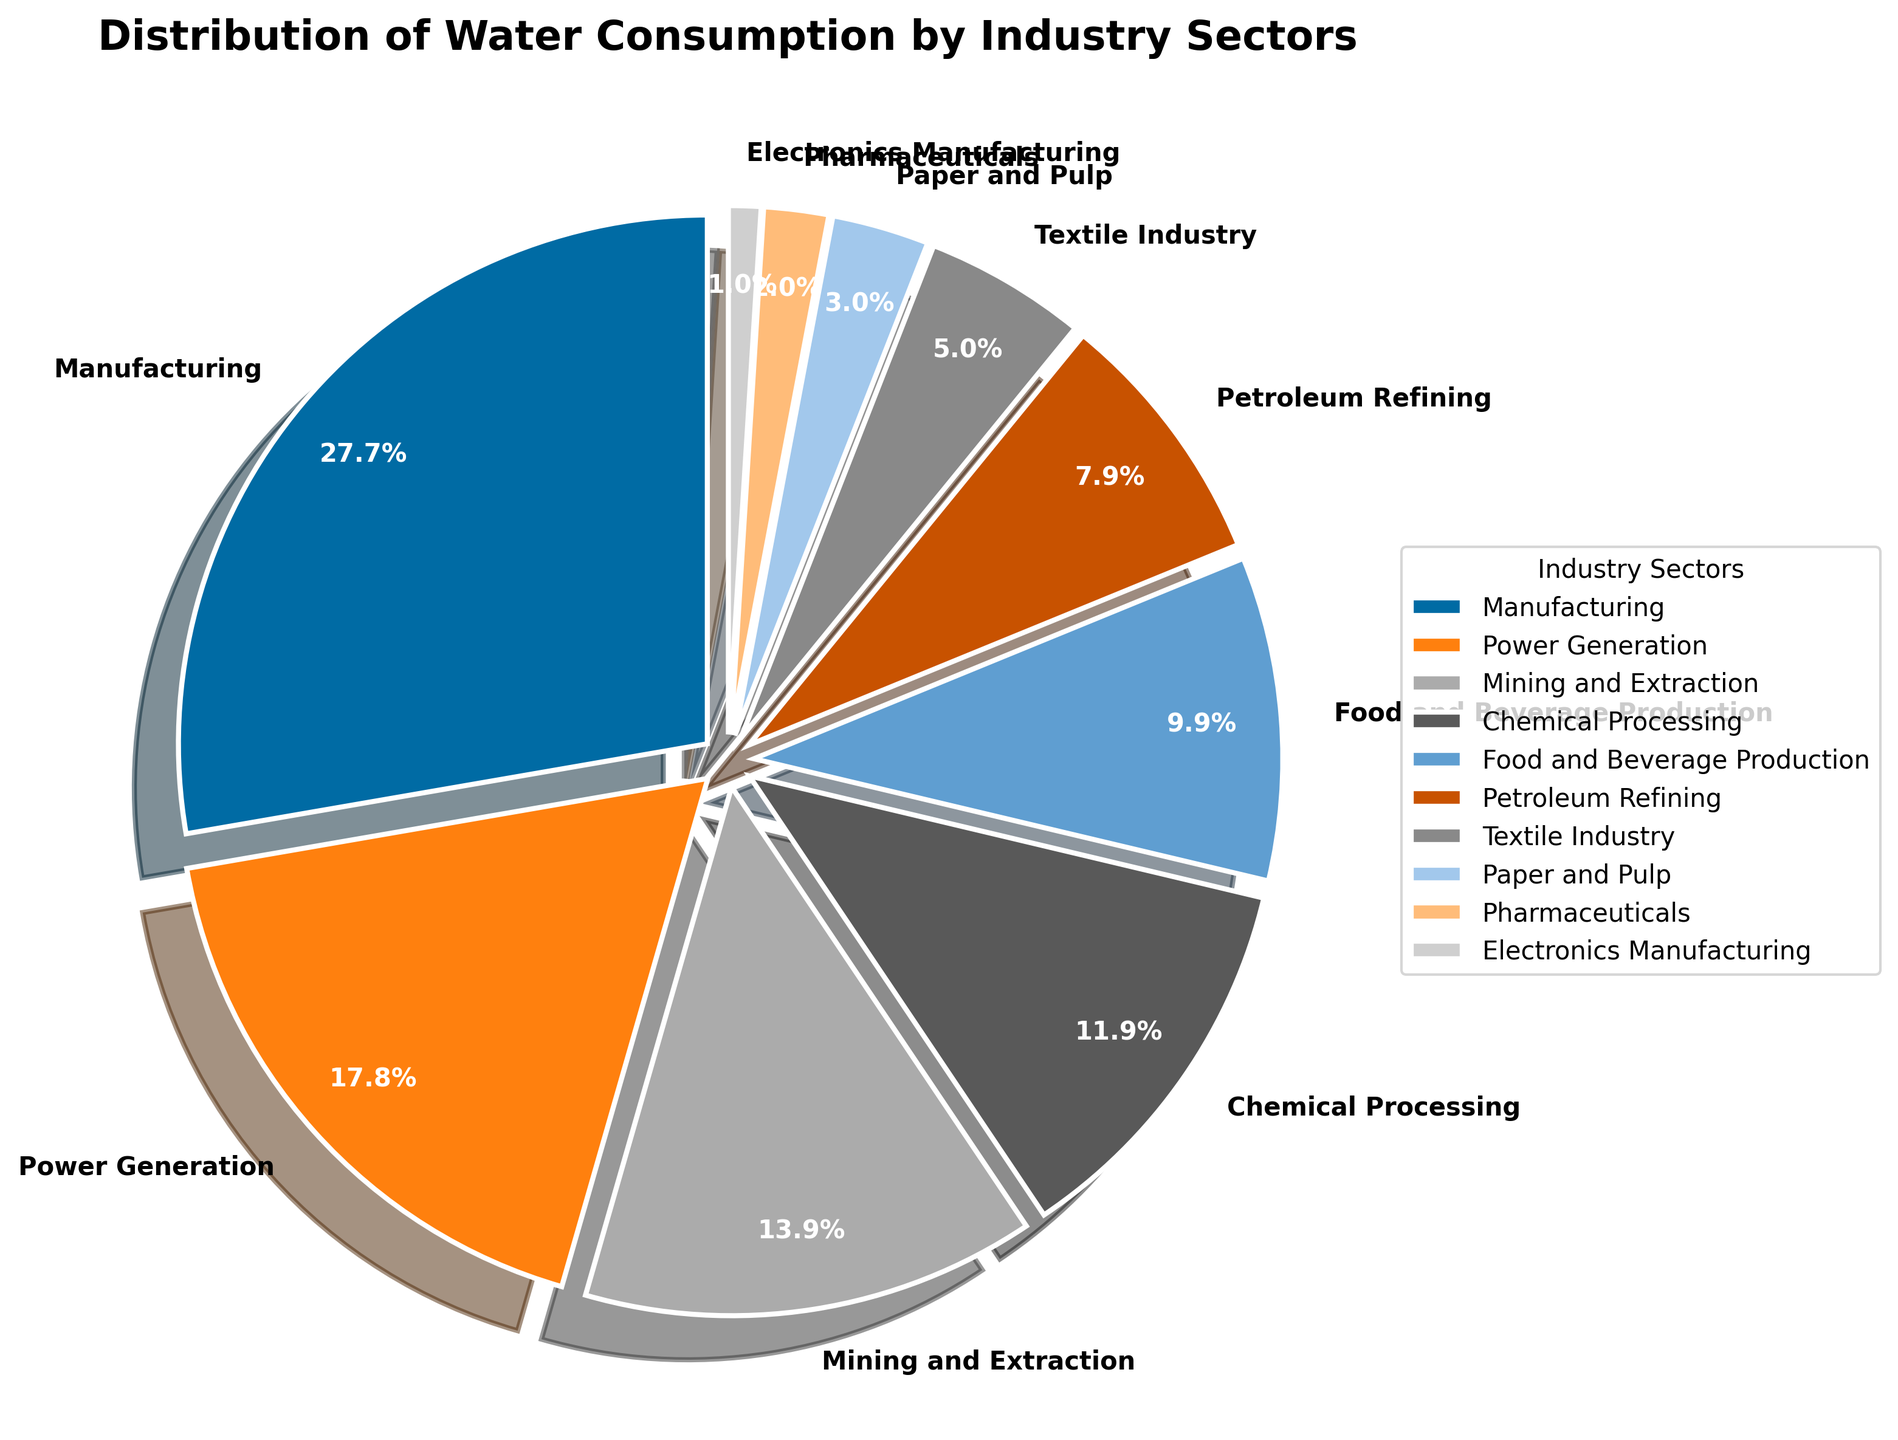Which industry sector consumes the most water? The pie chart indicates the water consumption percentage for each industry sector. Manufacturing has the largest share.
Answer: Manufacturing Which industry sector consumes the least water? According to the pie chart, Electronics Manufacturing has the smallest percentage of water consumption.
Answer: Electronics Manufacturing What is the combined water consumption percentage of Power Generation and Chemical Processing? The chart shows that Power Generation consumes 18% and Chemical Processing consumes 12%. Adding these gives 18% + 12% = 30%.
Answer: 30% How much more water does Manufacturing consume compared to Petroleum Refining? From the pie chart, Manufacturing consumes 28% and Petroleum Refining consumes 8%. The difference is 28% - 8% = 20%.
Answer: 20% Is the water consumption by the Food and Beverage Production sector closer to that of Mining and Extraction or to that of Chemical Processing? The pie chart shows Food and Beverage Production at 10%, Mining and Extraction at 14%, and Chemical Processing at 12%. The difference with Mining and Extraction is 4% (14% - 10%) and with Chemical Processing is 2% (12% - 10%). Thus, it is closer to Chemical Processing.
Answer: Chemical Processing What is the total water consumption percentage of the three smallest industry sectors? The three smallest sectors are Pharmaceuticals (2%), Electronics Manufacturing (1%), and Paper and Pulp (3%). Their combined consumption is 2% + 1% + 3% = 6%.
Answer: 6% Which industry sectors consume more than 10% of the total water? From the pie chart, the sectors consuming more than 10% are Manufacturing (28%), Power Generation (18%), Mining and Extraction (14%), and Chemical Processing (12%).
Answer: Manufacturing, Power Generation, Mining and Extraction, Chemical Processing How does the water consumption of the Textile Industry compare to that of the Paper and Pulp sector? The pie chart shows that the Textile Industry consumes 5% and the Paper and Pulp sector consumes 3%. Therefore, the Textile Industry consumes 2% more.
Answer: Textile Industry consumes 2% more What fraction of the total water consumption is used by the top three industry sectors? The top three sectors in water consumption are Manufacturing (28%), Power Generation (18%), and Mining and Extraction (14%). Their combined consumption is 28% + 18% + 14% = 60%.
Answer: 60% Is the water consumption of Chemical Processing greater or less than the sum of Pharmaceuticals and Electronics Manufacturing? Chemical Processing consumes 12%, while Pharmaceuticals and Electronics Manufacturing together consume 2% + 1% = 3%. Therefore, Chemical Processing consumes more.
Answer: Greater 